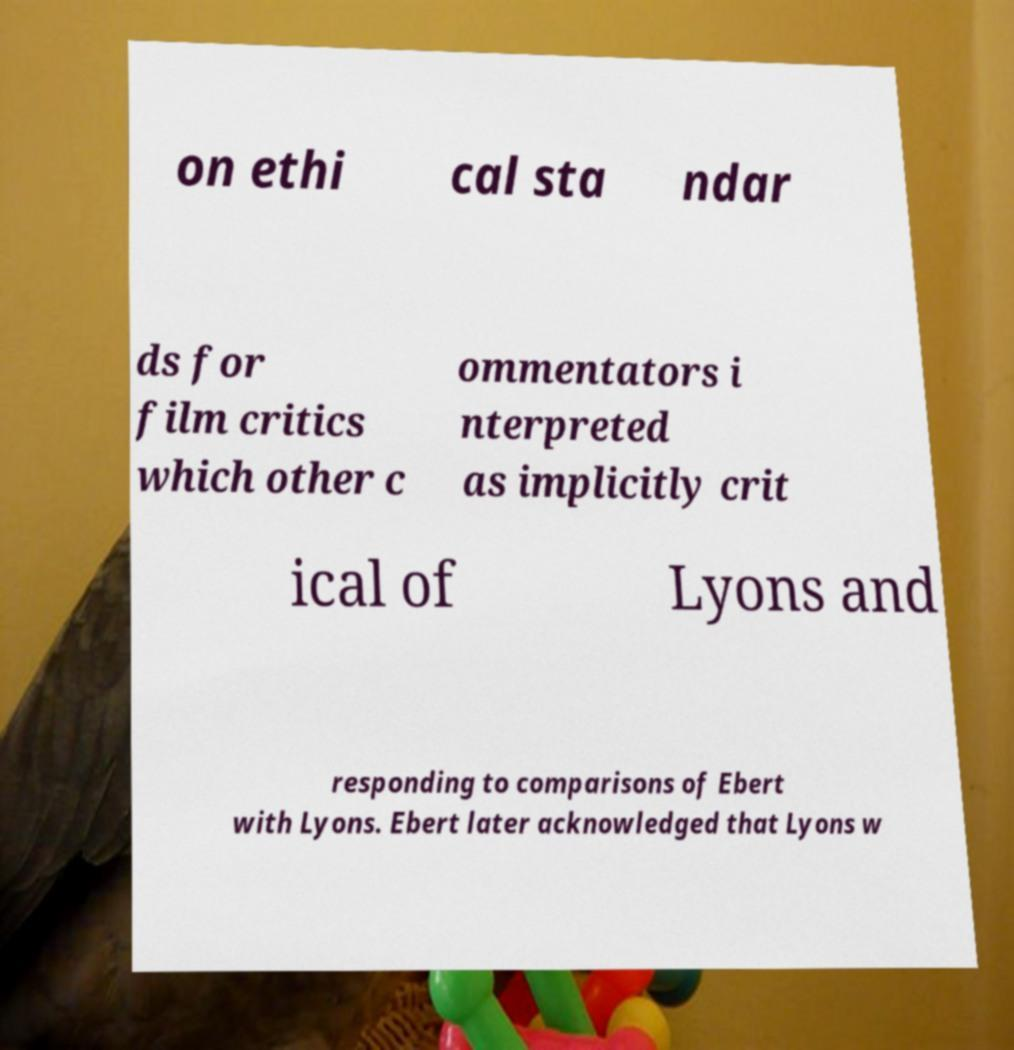Can you read and provide the text displayed in the image?This photo seems to have some interesting text. Can you extract and type it out for me? on ethi cal sta ndar ds for film critics which other c ommentators i nterpreted as implicitly crit ical of Lyons and responding to comparisons of Ebert with Lyons. Ebert later acknowledged that Lyons w 